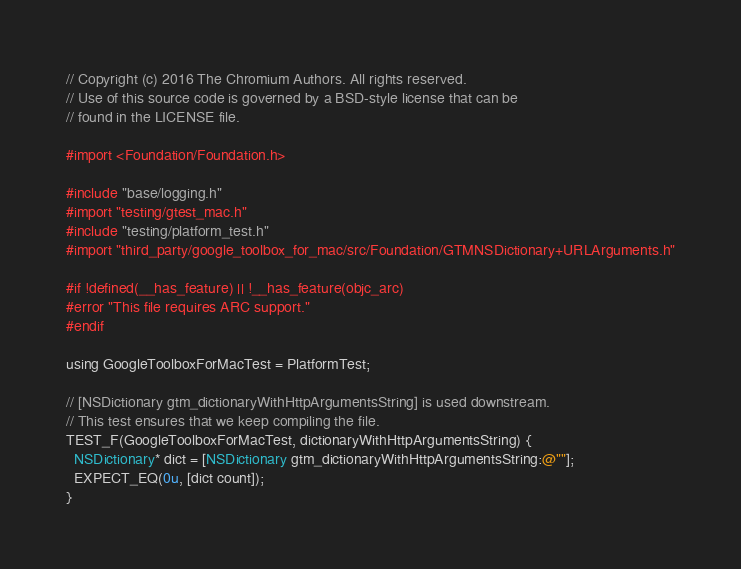<code> <loc_0><loc_0><loc_500><loc_500><_ObjectiveC_>// Copyright (c) 2016 The Chromium Authors. All rights reserved.
// Use of this source code is governed by a BSD-style license that can be
// found in the LICENSE file.

#import <Foundation/Foundation.h>

#include "base/logging.h"
#import "testing/gtest_mac.h"
#include "testing/platform_test.h"
#import "third_party/google_toolbox_for_mac/src/Foundation/GTMNSDictionary+URLArguments.h"

#if !defined(__has_feature) || !__has_feature(objc_arc)
#error "This file requires ARC support."
#endif

using GoogleToolboxForMacTest = PlatformTest;

// [NSDictionary gtm_dictionaryWithHttpArgumentsString] is used downstream.
// This test ensures that we keep compiling the file.
TEST_F(GoogleToolboxForMacTest, dictionaryWithHttpArgumentsString) {
  NSDictionary* dict = [NSDictionary gtm_dictionaryWithHttpArgumentsString:@""];
  EXPECT_EQ(0u, [dict count]);
}
</code> 